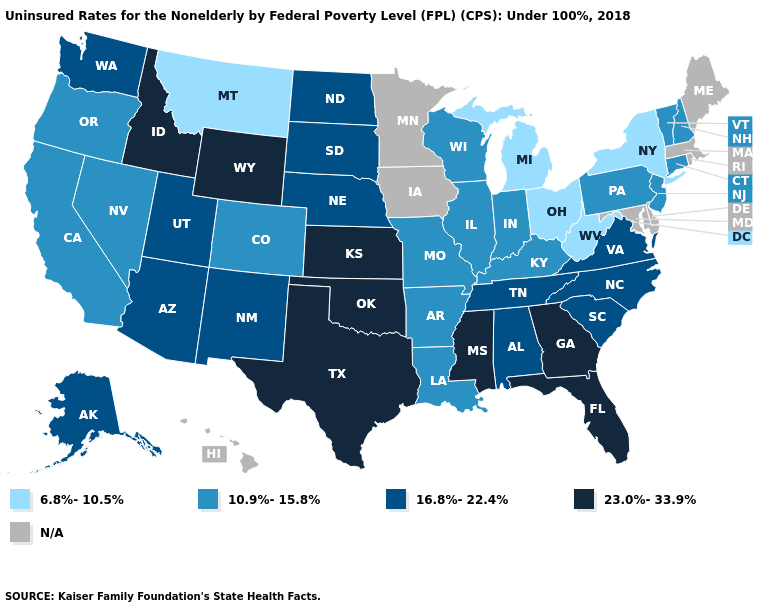What is the value of West Virginia?
Be succinct. 6.8%-10.5%. Does Kansas have the highest value in the USA?
Write a very short answer. Yes. Does Connecticut have the highest value in the Northeast?
Answer briefly. Yes. Among the states that border North Dakota , which have the lowest value?
Write a very short answer. Montana. Which states have the lowest value in the West?
Keep it brief. Montana. What is the value of Pennsylvania?
Quick response, please. 10.9%-15.8%. Name the states that have a value in the range N/A?
Concise answer only. Delaware, Hawaii, Iowa, Maine, Maryland, Massachusetts, Minnesota, Rhode Island. Name the states that have a value in the range 23.0%-33.9%?
Give a very brief answer. Florida, Georgia, Idaho, Kansas, Mississippi, Oklahoma, Texas, Wyoming. Which states have the lowest value in the USA?
Write a very short answer. Michigan, Montana, New York, Ohio, West Virginia. Name the states that have a value in the range 6.8%-10.5%?
Give a very brief answer. Michigan, Montana, New York, Ohio, West Virginia. What is the value of Kentucky?
Quick response, please. 10.9%-15.8%. What is the value of Illinois?
Quick response, please. 10.9%-15.8%. Does the map have missing data?
Quick response, please. Yes. Which states have the lowest value in the USA?
Give a very brief answer. Michigan, Montana, New York, Ohio, West Virginia. Name the states that have a value in the range 23.0%-33.9%?
Concise answer only. Florida, Georgia, Idaho, Kansas, Mississippi, Oklahoma, Texas, Wyoming. 